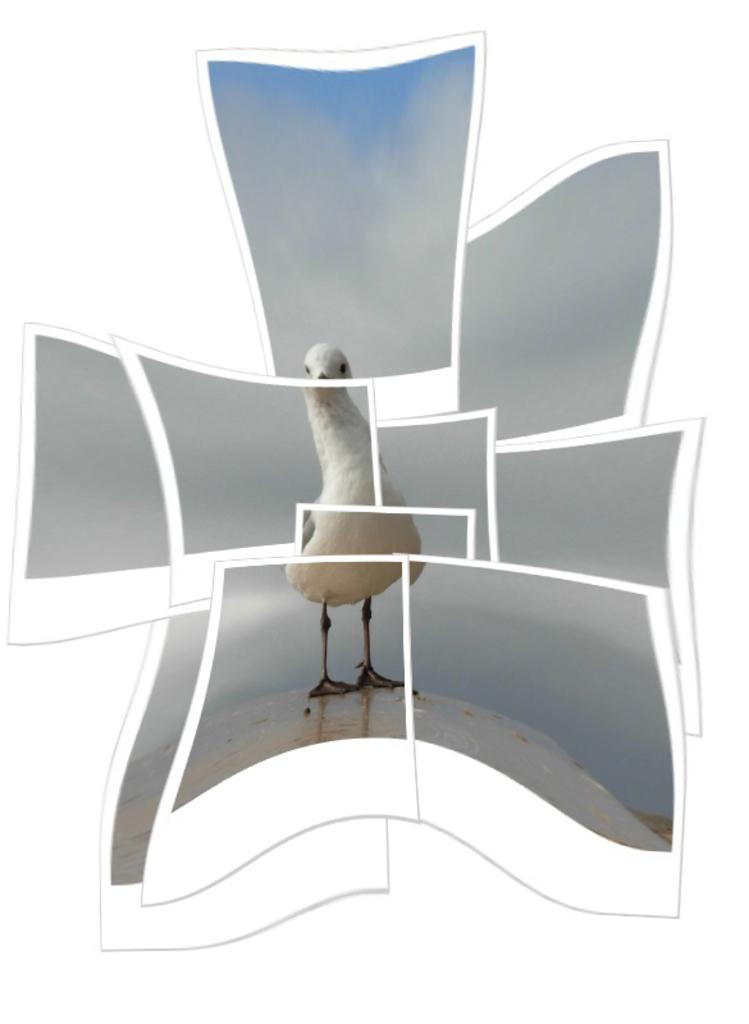What type of animal can be seen in the image? There is a bird in the image. What color is the bird? The bird is white in color. Where is the bird located in the image? The bird is standing on the ground. What can be seen in the background of the image? The sky is visible in the background of the image. Where can you purchase a ticket for the bird's performance in the image? There is no ticket or performance mentioned in the image; it simply shows a white bird standing on the ground. 